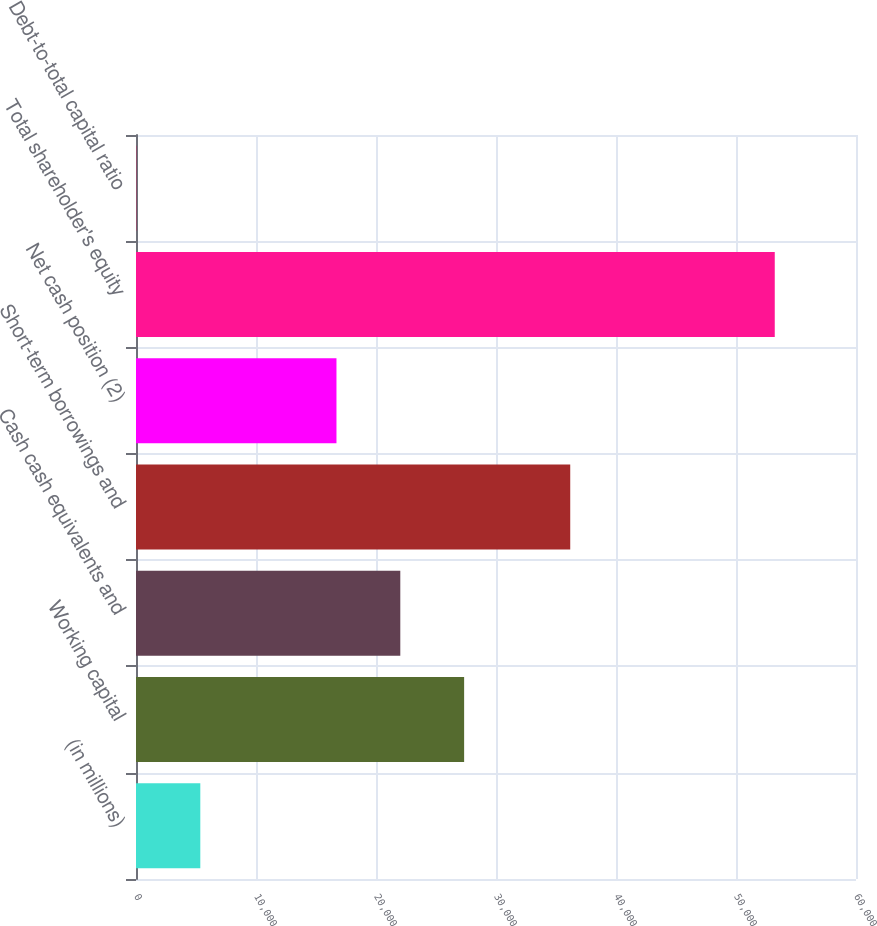Convert chart. <chart><loc_0><loc_0><loc_500><loc_500><bar_chart><fcel>(in millions)<fcel>Working capital<fcel>Cash cash equivalents and<fcel>Short-term borrowings and<fcel>Net cash position (2)<fcel>Total shareholder's equity<fcel>Debt-to-total capital ratio<nl><fcel>5359<fcel>27344<fcel>22025<fcel>36186<fcel>16706<fcel>53230<fcel>40<nl></chart> 